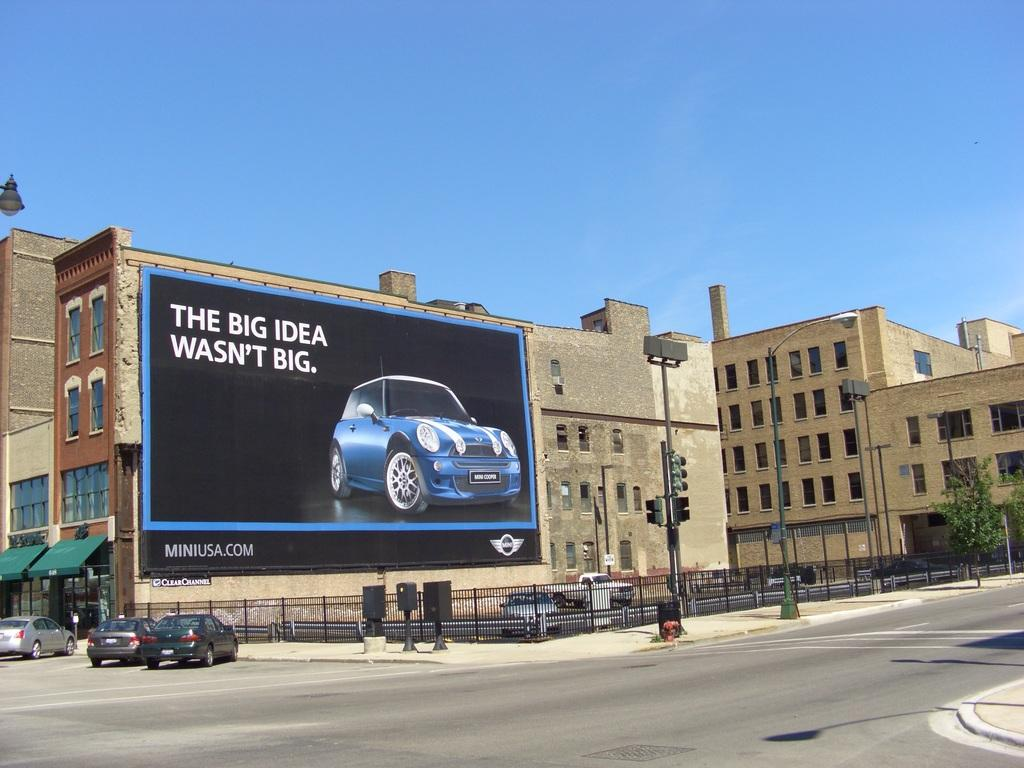<image>
Write a terse but informative summary of the picture. A billboard has a blue Mini Cooper ad that says The Big Idea Wasn't Big. 